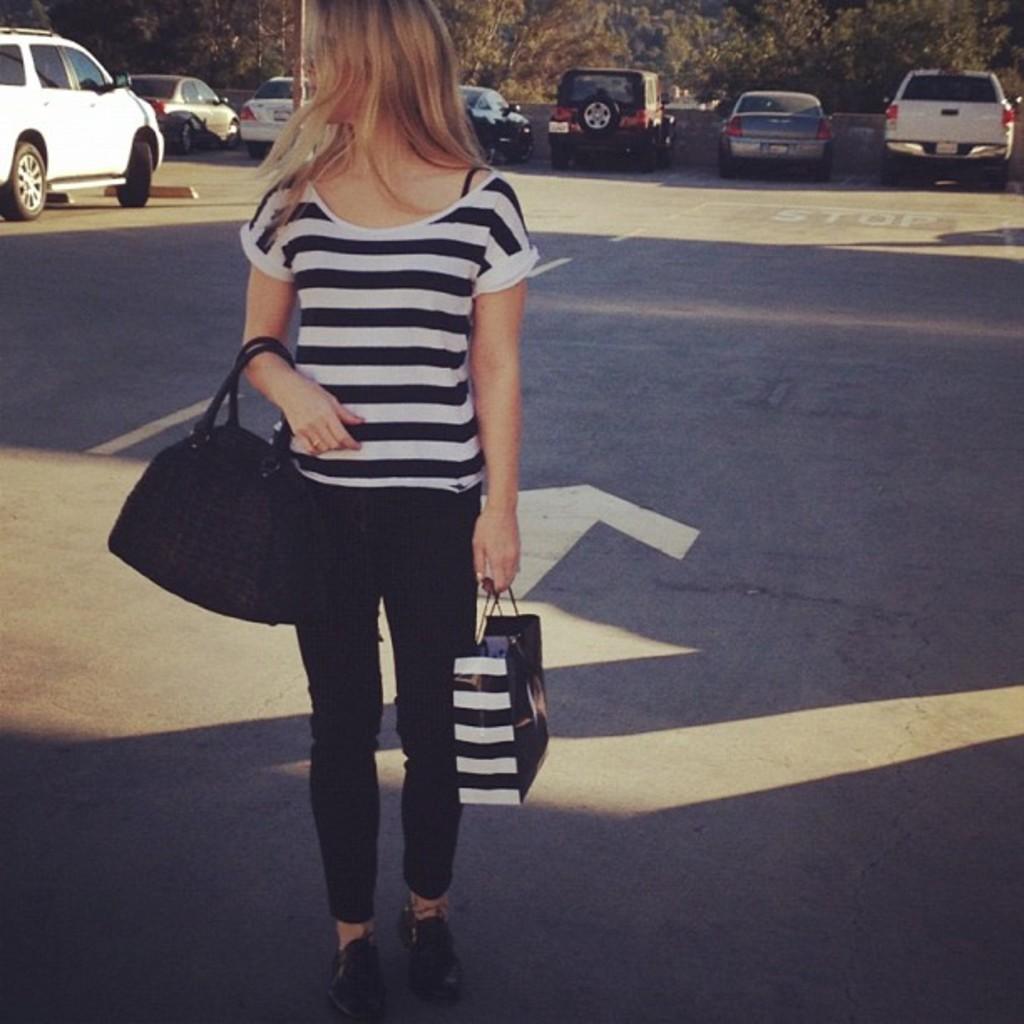Describe this image in one or two sentences. This picture might be taken on the wide road and it is sunny.. In this picture, on the left side, we can see a woman holding her handbag on one hand and carry bag on the other hand and the woman is standing on the road. In the background, we can see some cars, tree. At the top, we can see a sky, at the bottom there is a road. 